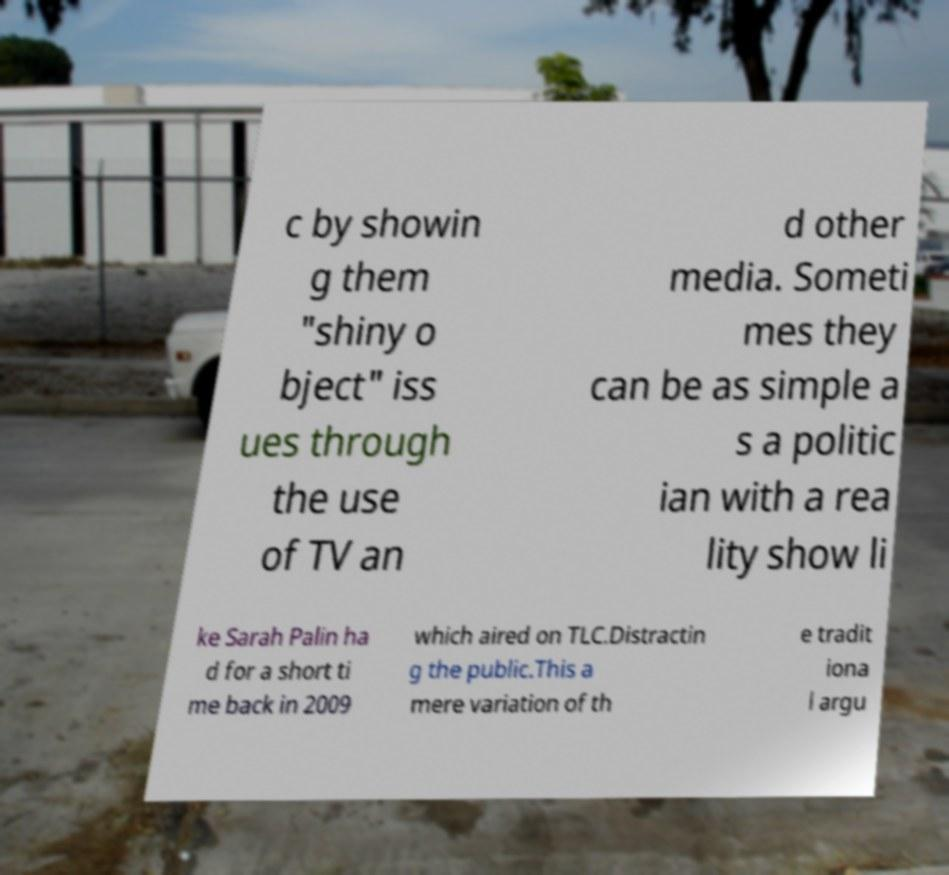Could you extract and type out the text from this image? c by showin g them "shiny o bject" iss ues through the use of TV an d other media. Someti mes they can be as simple a s a politic ian with a rea lity show li ke Sarah Palin ha d for a short ti me back in 2009 which aired on TLC.Distractin g the public.This a mere variation of th e tradit iona l argu 